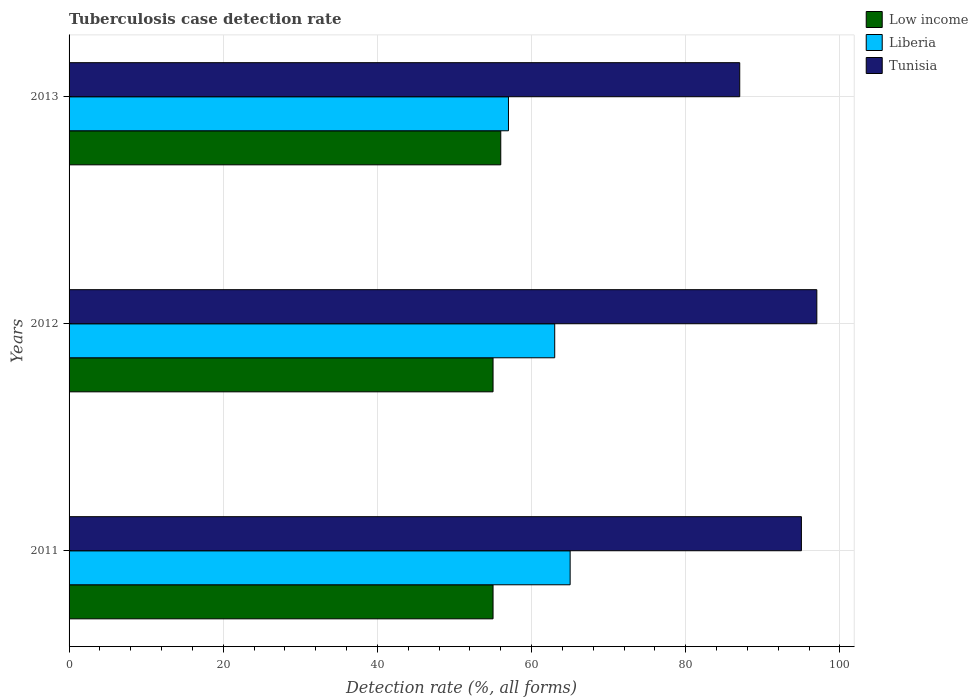Are the number of bars on each tick of the Y-axis equal?
Offer a terse response. Yes. How many bars are there on the 1st tick from the top?
Your response must be concise. 3. What is the label of the 3rd group of bars from the top?
Give a very brief answer. 2011. What is the tuberculosis case detection rate in in Low income in 2012?
Give a very brief answer. 55. Across all years, what is the maximum tuberculosis case detection rate in in Low income?
Your answer should be very brief. 56. What is the total tuberculosis case detection rate in in Tunisia in the graph?
Keep it short and to the point. 279. What is the difference between the tuberculosis case detection rate in in Liberia in 2011 and that in 2012?
Your response must be concise. 2. What is the difference between the tuberculosis case detection rate in in Low income in 2011 and the tuberculosis case detection rate in in Liberia in 2013?
Your answer should be compact. -2. What is the average tuberculosis case detection rate in in Low income per year?
Provide a short and direct response. 55.33. What is the ratio of the tuberculosis case detection rate in in Tunisia in 2012 to that in 2013?
Offer a terse response. 1.11. In how many years, is the tuberculosis case detection rate in in Liberia greater than the average tuberculosis case detection rate in in Liberia taken over all years?
Your answer should be very brief. 2. Is the sum of the tuberculosis case detection rate in in Low income in 2012 and 2013 greater than the maximum tuberculosis case detection rate in in Liberia across all years?
Ensure brevity in your answer.  Yes. What does the 2nd bar from the top in 2013 represents?
Ensure brevity in your answer.  Liberia. What does the 3rd bar from the bottom in 2011 represents?
Ensure brevity in your answer.  Tunisia. How many bars are there?
Ensure brevity in your answer.  9. How many years are there in the graph?
Give a very brief answer. 3. What is the difference between two consecutive major ticks on the X-axis?
Make the answer very short. 20. What is the title of the graph?
Keep it short and to the point. Tuberculosis case detection rate. What is the label or title of the X-axis?
Offer a very short reply. Detection rate (%, all forms). What is the Detection rate (%, all forms) in Low income in 2012?
Provide a short and direct response. 55. What is the Detection rate (%, all forms) of Tunisia in 2012?
Your answer should be compact. 97. What is the Detection rate (%, all forms) of Liberia in 2013?
Make the answer very short. 57. Across all years, what is the maximum Detection rate (%, all forms) in Low income?
Provide a succinct answer. 56. Across all years, what is the maximum Detection rate (%, all forms) in Tunisia?
Keep it short and to the point. 97. What is the total Detection rate (%, all forms) in Low income in the graph?
Keep it short and to the point. 166. What is the total Detection rate (%, all forms) in Liberia in the graph?
Give a very brief answer. 185. What is the total Detection rate (%, all forms) of Tunisia in the graph?
Your response must be concise. 279. What is the difference between the Detection rate (%, all forms) in Tunisia in 2011 and that in 2012?
Offer a terse response. -2. What is the difference between the Detection rate (%, all forms) in Tunisia in 2011 and that in 2013?
Provide a short and direct response. 8. What is the difference between the Detection rate (%, all forms) of Low income in 2011 and the Detection rate (%, all forms) of Tunisia in 2012?
Ensure brevity in your answer.  -42. What is the difference between the Detection rate (%, all forms) of Liberia in 2011 and the Detection rate (%, all forms) of Tunisia in 2012?
Your response must be concise. -32. What is the difference between the Detection rate (%, all forms) in Low income in 2011 and the Detection rate (%, all forms) in Tunisia in 2013?
Ensure brevity in your answer.  -32. What is the difference between the Detection rate (%, all forms) of Low income in 2012 and the Detection rate (%, all forms) of Liberia in 2013?
Your answer should be very brief. -2. What is the difference between the Detection rate (%, all forms) of Low income in 2012 and the Detection rate (%, all forms) of Tunisia in 2013?
Ensure brevity in your answer.  -32. What is the average Detection rate (%, all forms) of Low income per year?
Keep it short and to the point. 55.33. What is the average Detection rate (%, all forms) of Liberia per year?
Ensure brevity in your answer.  61.67. What is the average Detection rate (%, all forms) in Tunisia per year?
Offer a very short reply. 93. In the year 2011, what is the difference between the Detection rate (%, all forms) in Low income and Detection rate (%, all forms) in Liberia?
Give a very brief answer. -10. In the year 2011, what is the difference between the Detection rate (%, all forms) in Liberia and Detection rate (%, all forms) in Tunisia?
Provide a short and direct response. -30. In the year 2012, what is the difference between the Detection rate (%, all forms) of Low income and Detection rate (%, all forms) of Tunisia?
Your answer should be very brief. -42. In the year 2012, what is the difference between the Detection rate (%, all forms) of Liberia and Detection rate (%, all forms) of Tunisia?
Provide a short and direct response. -34. In the year 2013, what is the difference between the Detection rate (%, all forms) of Low income and Detection rate (%, all forms) of Liberia?
Your answer should be very brief. -1. In the year 2013, what is the difference between the Detection rate (%, all forms) of Low income and Detection rate (%, all forms) of Tunisia?
Provide a succinct answer. -31. In the year 2013, what is the difference between the Detection rate (%, all forms) in Liberia and Detection rate (%, all forms) in Tunisia?
Give a very brief answer. -30. What is the ratio of the Detection rate (%, all forms) of Low income in 2011 to that in 2012?
Provide a succinct answer. 1. What is the ratio of the Detection rate (%, all forms) of Liberia in 2011 to that in 2012?
Provide a short and direct response. 1.03. What is the ratio of the Detection rate (%, all forms) of Tunisia in 2011 to that in 2012?
Ensure brevity in your answer.  0.98. What is the ratio of the Detection rate (%, all forms) in Low income in 2011 to that in 2013?
Offer a terse response. 0.98. What is the ratio of the Detection rate (%, all forms) in Liberia in 2011 to that in 2013?
Provide a short and direct response. 1.14. What is the ratio of the Detection rate (%, all forms) of Tunisia in 2011 to that in 2013?
Your response must be concise. 1.09. What is the ratio of the Detection rate (%, all forms) of Low income in 2012 to that in 2013?
Your answer should be very brief. 0.98. What is the ratio of the Detection rate (%, all forms) of Liberia in 2012 to that in 2013?
Provide a short and direct response. 1.11. What is the ratio of the Detection rate (%, all forms) in Tunisia in 2012 to that in 2013?
Make the answer very short. 1.11. What is the difference between the highest and the lowest Detection rate (%, all forms) of Low income?
Offer a very short reply. 1. What is the difference between the highest and the lowest Detection rate (%, all forms) of Liberia?
Provide a short and direct response. 8. 